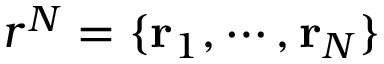Convert formula to latex. <formula><loc_0><loc_0><loc_500><loc_500>r ^ { N } = \{ r _ { 1 } , \cdots , r _ { N } \}</formula> 